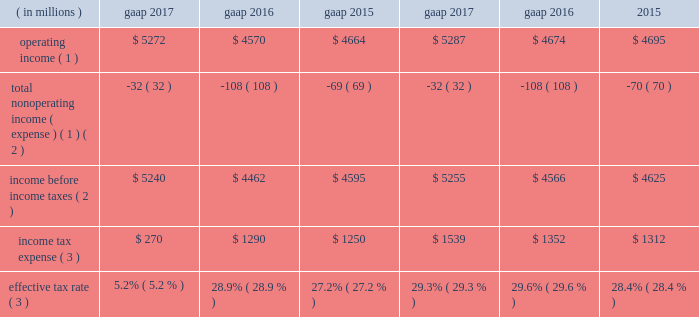Income tax expense .
Operating income ( 1 ) $ 5272 $ 4570 $ 4664 $ 5287 $ 4674 $ 4695 total nonoperating income ( expense ) ( 1 ) ( 2 ) ( 32 ) ( 108 ) ( 69 ) ( 32 ) ( 108 ) ( 70 ) income before income taxes ( 2 ) $ 5240 $ 4462 $ 4595 $ 5255 $ 4566 $ 4625 income tax expense ( 3 ) $ 270 $ 1290 $ 1250 $ 1539 $ 1352 $ 1312 effective tax rate ( 3 ) 5.2% ( 5.2 % ) 28.9% ( 28.9 % ) 27.2% ( 27.2 % ) 29.3% ( 29.3 % ) 29.6% ( 29.6 % ) 28.4% ( 28.4 % ) ( 1 ) see non-gaap financial measures for further information on and reconciliation of as adjusted items .
( 2 ) net of net income ( loss ) attributable to nci .
( 3 ) gaap income tax expense and effective tax rate for 2017 reflects $ 1.2 billion of a net tax benefit related to the 2017 tax act .
The company 2019s tax rate is affected by tax rates in foreign jurisdictions and the relative amount of income earned in those jurisdictions , which the company expects to be fairly consistent in the near term .
The significant foreign jurisdictions that have lower statutory tax rates than the u.s .
Federal statutory rate of 35% ( 35 % ) include the united kingdom , channel islands , ireland and netherlands .
2017 .
Income tax expense ( gaap ) reflected : 2022 the following amounts related to the 2017 tax act : 2022 $ 106 million tax expense related to the revaluation of certain deferred income tax assets ; 2022 $ 1758 million noncash tax benefit related to the revaluation of certain deferred income tax liabilities ; 2022 $ 477 million tax expense related to the mandatory deemed repatriation of undistributed foreign earnings and profits .
2022 a noncash expense of $ 16 million , primarily associated with the revaluation of certain deferred income tax liabilities as a result of domestic state and local tax changes ; and 2022 $ 173 million discrete tax benefits , primarily related to stock-based compensation awards , including $ 151 million related to the adoption of new accounting guidance related to stock-based compensation awards .
See note 2 , significant accounting policies , for further information .
The as adjusted effective tax rate of 29.3% ( 29.3 % ) for 2017 excluded the noncash deferred tax revaluation benefit of $ 1758 million and noncash expense of $ 16 million mentioned above as it will not have a cash flow impact and to ensure comparability among periods presented .
In addition , the deemed repatriation tax expense of $ 477 million has been excluded from the as adjusted results due to the one-time nature and to ensure comparability among periods presented .
2016 .
Income tax expense ( gaap ) reflected : 2022 a net noncash benefit of $ 30 million , primarily associated with the revaluation of certain deferred income tax liabilities ; and 2022 a benefit from $ 65 million of nonrecurring items , including the resolution of certain outstanding tax matters .
The as adjusted effective tax rate of 29.6% ( 29.6 % ) for 2016 excluded the net noncash benefit of $ 30 million mentioned above as it will not have a cash flow impact and to ensure comparability among periods presented .
2015 .
Income tax expense ( gaap ) reflected : 2022 a net noncash benefit of $ 54 million , primarily associated with the revaluation of certain deferred income tax liabilities ; and 2022 a benefit from $ 75 million of nonrecurring items , primarily due to the realization of losses from changes in the company 2019s organizational tax structure and the resolution of certain outstanding tax matters .
The as adjusted effective tax rate of 28.4% ( 28.4 % ) for 2015 excluded the net noncash benefit of $ 54 million mentioned above , as it will not have a cash flow impact and to ensure comparability among periods presented .
Balance sheet overview as adjusted balance sheet the following table presents a reconciliation of the consolidated statement of financial condition presented on a gaap basis to the consolidated statement of financial condition , excluding the impact of separate account assets and separate account collateral held under securities lending agreements ( directly related to lending separate account securities ) and separate account liabilities and separate account collateral liabilities under securities lending agreements and consolidated sponsored investment funds , including consolidated vies .
The company presents the as adjusted balance sheet as additional information to enable investors to exclude certain assets that have equal and offsetting liabilities or noncontrolling interests that ultimately do not have an impact on stockholders 2019 equity or cash flows .
Management views the as adjusted balance sheet , which contains non-gaap financial measures , as an economic presentation of the company 2019s total assets and liabilities ; however , it does not advocate that investors consider such non-gaap financial measures in isolation from , or as a substitute for , financial information prepared in accordance with gaap .
Separate account assets and liabilities and separate account collateral held under securities lending agreements separate account assets are maintained by blackrock life limited , a wholly owned subsidiary of the company that is a registered life insurance company in the united kingdom , and represent segregated assets held for purposes of funding individual and group pension contracts .
The .
What is the growth rate in operating income from 2015 to 2016? 
Computations: ((4570 - 4664) / 4664)
Answer: -0.02015. 